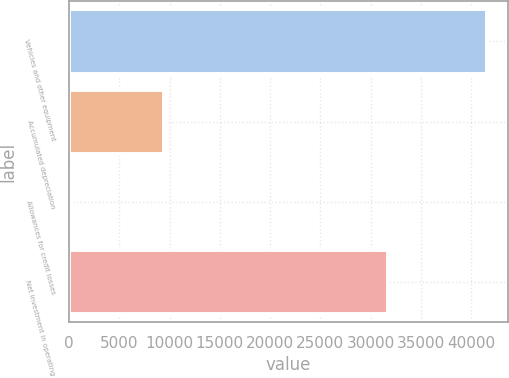Convert chart. <chart><loc_0><loc_0><loc_500><loc_500><bar_chart><fcel>Vehicles and other equipment<fcel>Accumulated depreciation<fcel>Allowances for credit losses<fcel>Net investment in operating<nl><fcel>41545<fcel>9477<fcel>305<fcel>31763<nl></chart> 